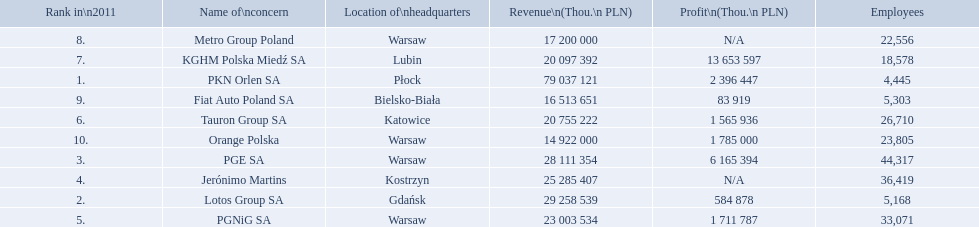What are the names of the major companies of poland? PKN Orlen SA, Lotos Group SA, PGE SA, Jerónimo Martins, PGNiG SA, Tauron Group SA, KGHM Polska Miedź SA, Metro Group Poland, Fiat Auto Poland SA, Orange Polska. What are the revenues of those companies in thou. pln? PKN Orlen SA, 79 037 121, Lotos Group SA, 29 258 539, PGE SA, 28 111 354, Jerónimo Martins, 25 285 407, PGNiG SA, 23 003 534, Tauron Group SA, 20 755 222, KGHM Polska Miedź SA, 20 097 392, Metro Group Poland, 17 200 000, Fiat Auto Poland SA, 16 513 651, Orange Polska, 14 922 000. Which of these revenues is greater than 75 000 000 thou. pln? 79 037 121. Which company has a revenue equal to 79 037 121 thou pln? PKN Orlen SA. What are the names of all the concerns? PKN Orlen SA, Lotos Group SA, PGE SA, Jerónimo Martins, PGNiG SA, Tauron Group SA, KGHM Polska Miedź SA, Metro Group Poland, Fiat Auto Poland SA, Orange Polska. How many employees does pgnig sa have? 33,071. 